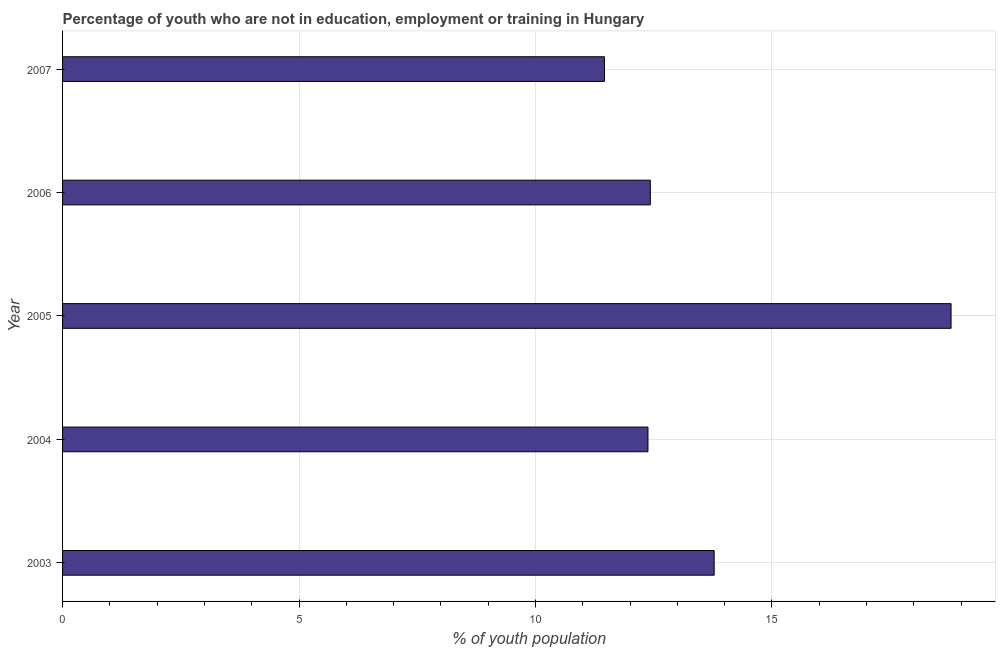Does the graph contain any zero values?
Give a very brief answer. No. Does the graph contain grids?
Offer a terse response. Yes. What is the title of the graph?
Provide a succinct answer. Percentage of youth who are not in education, employment or training in Hungary. What is the label or title of the X-axis?
Offer a very short reply. % of youth population. What is the unemployed youth population in 2004?
Your response must be concise. 12.38. Across all years, what is the maximum unemployed youth population?
Make the answer very short. 18.79. Across all years, what is the minimum unemployed youth population?
Provide a short and direct response. 11.46. In which year was the unemployed youth population maximum?
Make the answer very short. 2005. What is the sum of the unemployed youth population?
Your response must be concise. 68.84. What is the difference between the unemployed youth population in 2003 and 2004?
Keep it short and to the point. 1.4. What is the average unemployed youth population per year?
Give a very brief answer. 13.77. What is the median unemployed youth population?
Give a very brief answer. 12.43. In how many years, is the unemployed youth population greater than 16 %?
Keep it short and to the point. 1. What is the ratio of the unemployed youth population in 2003 to that in 2007?
Keep it short and to the point. 1.2. Is the difference between the unemployed youth population in 2005 and 2006 greater than the difference between any two years?
Make the answer very short. No. What is the difference between the highest and the second highest unemployed youth population?
Your response must be concise. 5.01. What is the difference between the highest and the lowest unemployed youth population?
Offer a very short reply. 7.33. What is the difference between two consecutive major ticks on the X-axis?
Offer a very short reply. 5. Are the values on the major ticks of X-axis written in scientific E-notation?
Keep it short and to the point. No. What is the % of youth population in 2003?
Provide a short and direct response. 13.78. What is the % of youth population in 2004?
Offer a terse response. 12.38. What is the % of youth population in 2005?
Give a very brief answer. 18.79. What is the % of youth population in 2006?
Your answer should be very brief. 12.43. What is the % of youth population of 2007?
Provide a short and direct response. 11.46. What is the difference between the % of youth population in 2003 and 2005?
Your answer should be very brief. -5.01. What is the difference between the % of youth population in 2003 and 2006?
Your answer should be very brief. 1.35. What is the difference between the % of youth population in 2003 and 2007?
Your answer should be compact. 2.32. What is the difference between the % of youth population in 2004 and 2005?
Provide a short and direct response. -6.41. What is the difference between the % of youth population in 2004 and 2006?
Offer a terse response. -0.05. What is the difference between the % of youth population in 2005 and 2006?
Your response must be concise. 6.36. What is the difference between the % of youth population in 2005 and 2007?
Keep it short and to the point. 7.33. What is the ratio of the % of youth population in 2003 to that in 2004?
Offer a very short reply. 1.11. What is the ratio of the % of youth population in 2003 to that in 2005?
Keep it short and to the point. 0.73. What is the ratio of the % of youth population in 2003 to that in 2006?
Your answer should be very brief. 1.11. What is the ratio of the % of youth population in 2003 to that in 2007?
Ensure brevity in your answer.  1.2. What is the ratio of the % of youth population in 2004 to that in 2005?
Provide a short and direct response. 0.66. What is the ratio of the % of youth population in 2004 to that in 2006?
Make the answer very short. 1. What is the ratio of the % of youth population in 2005 to that in 2006?
Ensure brevity in your answer.  1.51. What is the ratio of the % of youth population in 2005 to that in 2007?
Your response must be concise. 1.64. What is the ratio of the % of youth population in 2006 to that in 2007?
Keep it short and to the point. 1.08. 